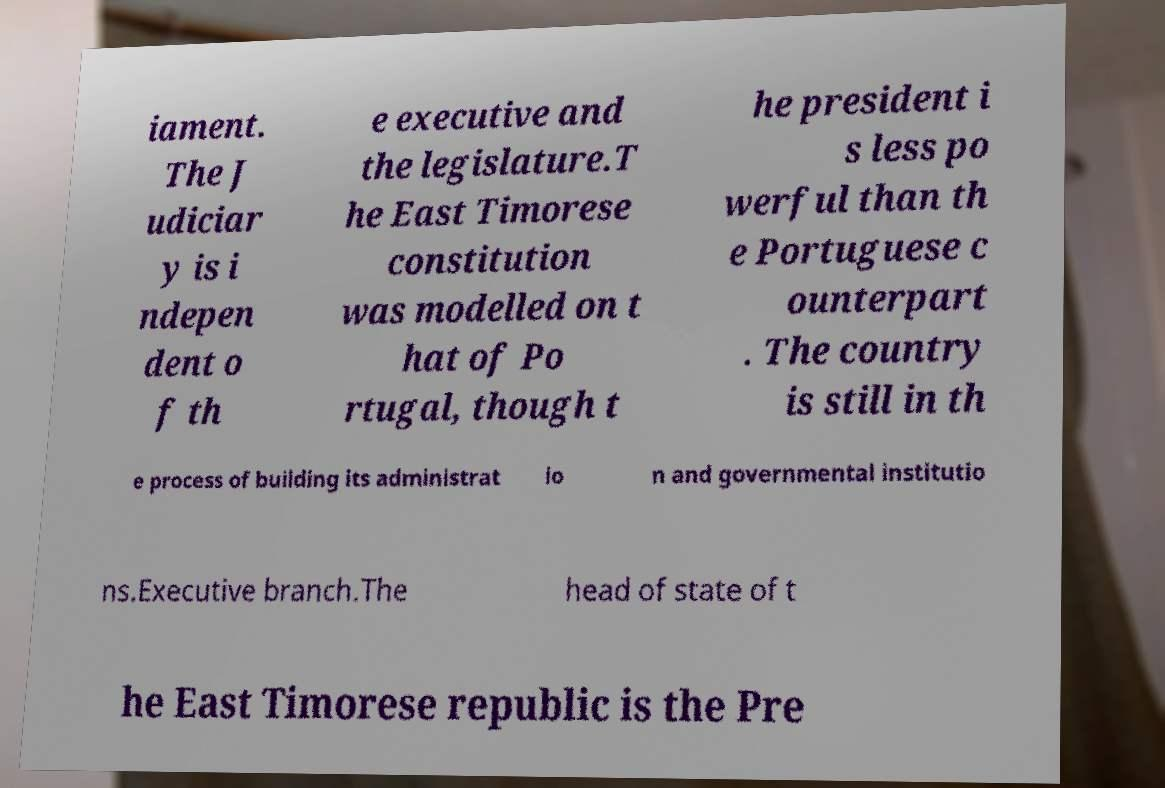Please identify and transcribe the text found in this image. iament. The J udiciar y is i ndepen dent o f th e executive and the legislature.T he East Timorese constitution was modelled on t hat of Po rtugal, though t he president i s less po werful than th e Portuguese c ounterpart . The country is still in th e process of building its administrat io n and governmental institutio ns.Executive branch.The head of state of t he East Timorese republic is the Pre 